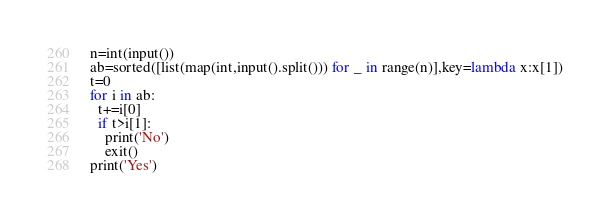Convert code to text. <code><loc_0><loc_0><loc_500><loc_500><_Python_>n=int(input())
ab=sorted([list(map(int,input().split())) for _ in range(n)],key=lambda x:x[1])
t=0
for i in ab:
  t+=i[0]
  if t>i[1]:
    print('No')
    exit()
print('Yes')</code> 